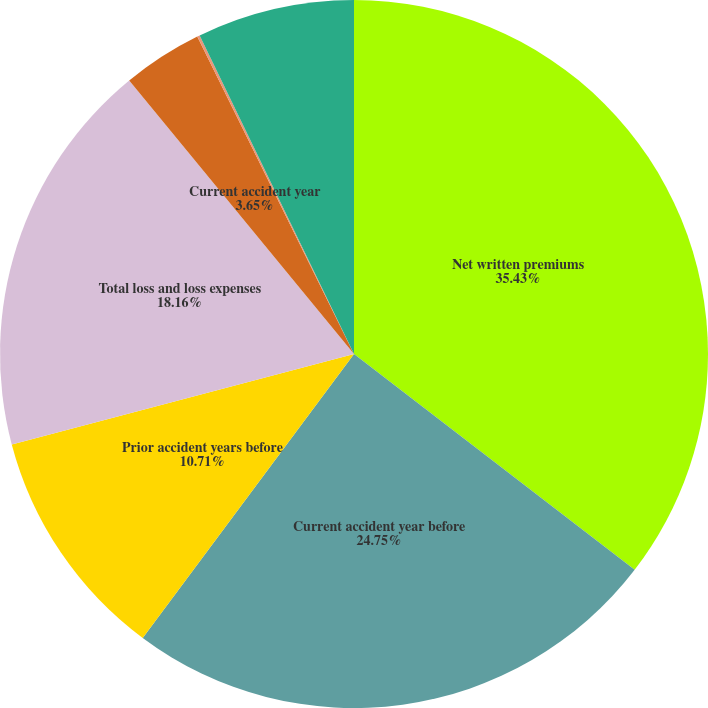<chart> <loc_0><loc_0><loc_500><loc_500><pie_chart><fcel>Net written premiums<fcel>Current accident year before<fcel>Prior accident years before<fcel>Total loss and loss expenses<fcel>Current accident year<fcel>Prior accident years<fcel>Total loss and loss expense<nl><fcel>35.43%<fcel>24.75%<fcel>10.71%<fcel>18.16%<fcel>3.65%<fcel>0.12%<fcel>7.18%<nl></chart> 